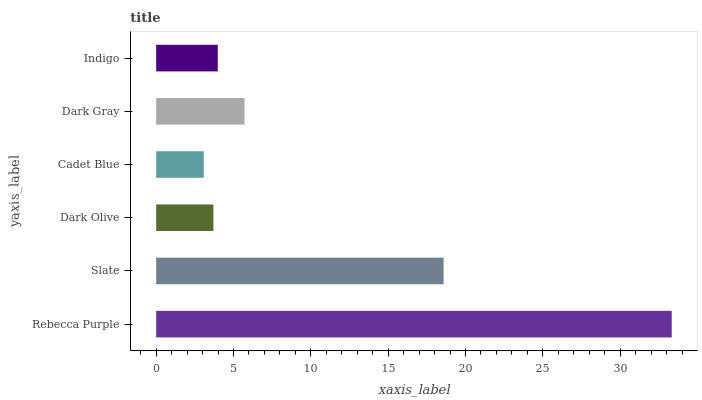Is Cadet Blue the minimum?
Answer yes or no. Yes. Is Rebecca Purple the maximum?
Answer yes or no. Yes. Is Slate the minimum?
Answer yes or no. No. Is Slate the maximum?
Answer yes or no. No. Is Rebecca Purple greater than Slate?
Answer yes or no. Yes. Is Slate less than Rebecca Purple?
Answer yes or no. Yes. Is Slate greater than Rebecca Purple?
Answer yes or no. No. Is Rebecca Purple less than Slate?
Answer yes or no. No. Is Dark Gray the high median?
Answer yes or no. Yes. Is Indigo the low median?
Answer yes or no. Yes. Is Rebecca Purple the high median?
Answer yes or no. No. Is Dark Olive the low median?
Answer yes or no. No. 